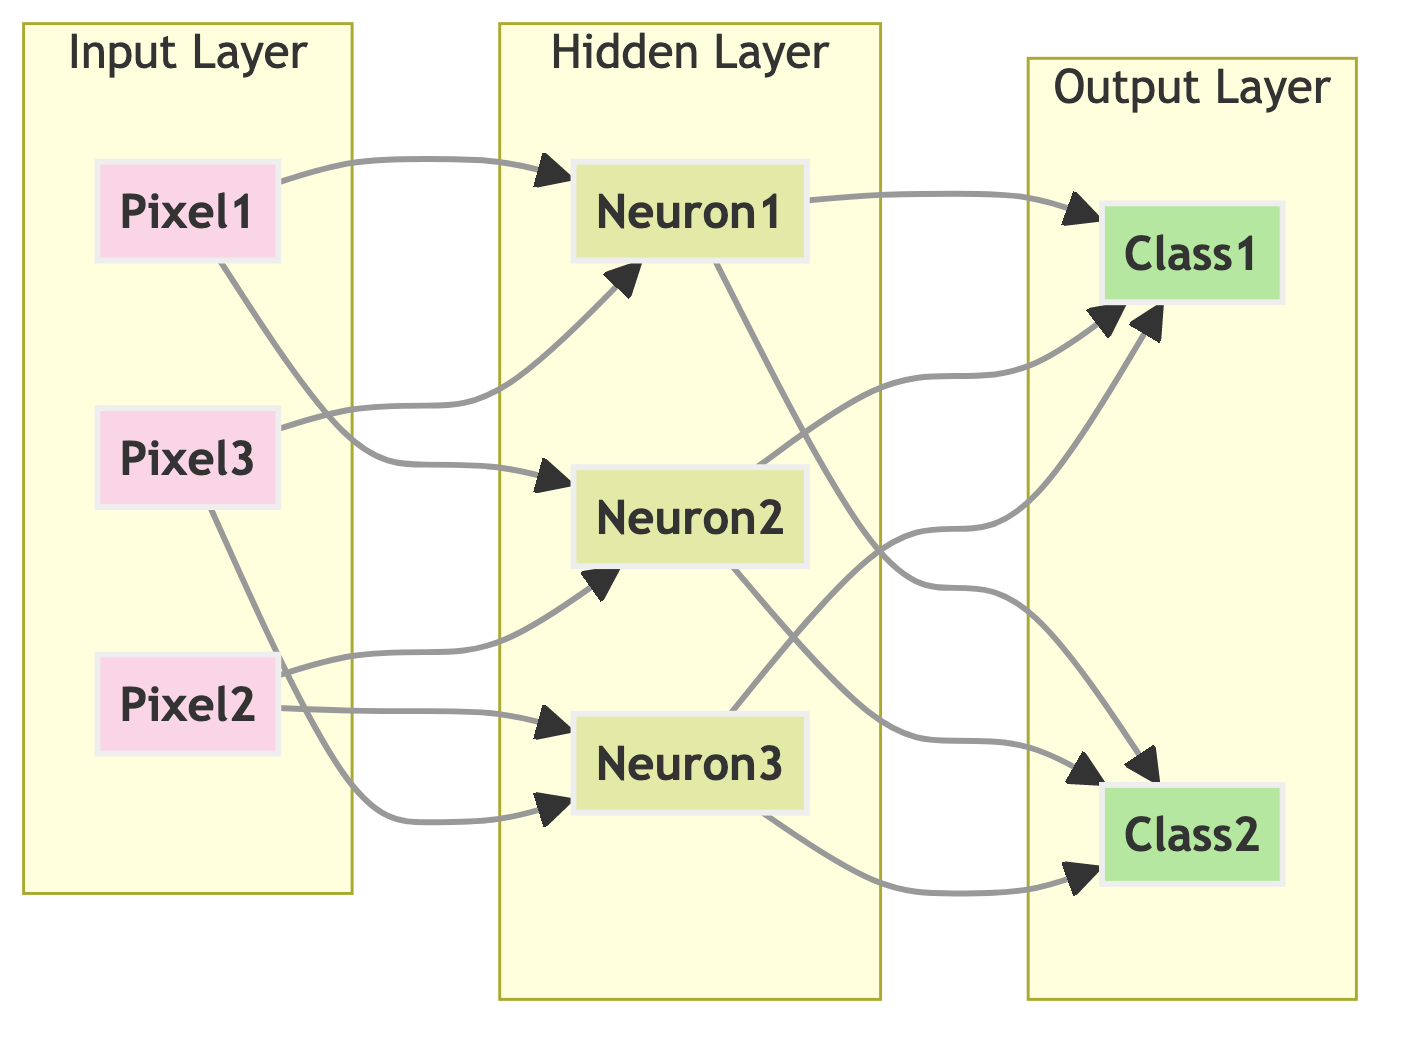what layers are present in the diagram? The diagram illustrates three layers: the input layer, hidden layer, and output layer. Each layer serves a different function in neural network processing.
Answer: input layer, hidden layer, output layer how many neurons are in the hidden layer? The hidden layer consists of three neurons as indicated by three labeled nodes within the hidden layer subsection.
Answer: 3 which input is connected to the first neuron in the hidden layer? The first neuron in the hidden layer is connected to Pixel1 and also receives input from Pixel3, as represented by the directed arrows leading to it.
Answer: Pixel1, Pixel3 how many outputs are there in the output layer? The output layer contains two classes, as shown by two labeled nodes within the output layer subsection.
Answer: 2 which inputs connect to the second neuron in the hidden layer? The second neuron in the hidden layer receives connections from Pixel2 and Pixel3, as indicated by the arrows leading to the second neuron.
Answer: Pixel2, Pixel3 what does the hidden layer do before passing its output? The hidden layer processes inputs from the input layer and produces outputs that can classify the input data into two categories represented in the output layer. It combines and transforms inputs before passing them along.
Answer: process inputs if an input reaches hidden neuron 2, what is the next step? Once an input reaches hidden neuron 2, it will forward its output along with the outputs from the other hidden neurons to the output layer, resulting in a classification between Class1 and Class2.
Answer: proceed to output layer what is the role of the input layer? The input layer collects and passes raw data (in this case, pixels) into the neural network for processing in the hidden layer.
Answer: collect and pass raw data how are the hidden layer neurons connected to the outputs? All three hidden neurons connect to both output classes, indicating that the processing done by hidden neurons influences the final classification results provided by the output layer.
Answer: connected to all outputs 